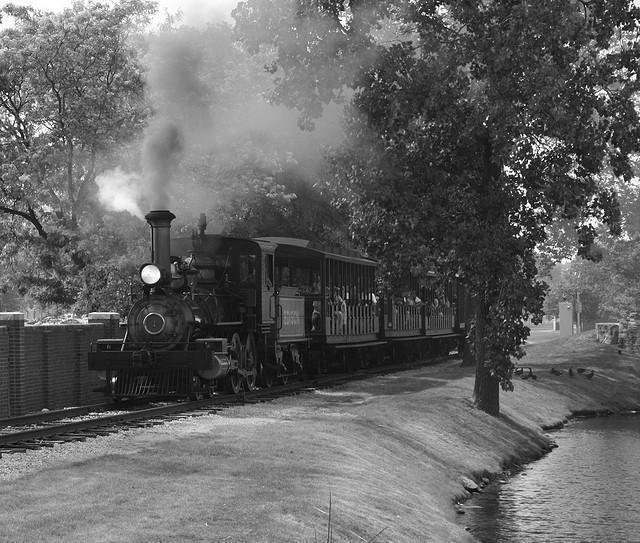What is the state of the colors here?
Indicate the correct choice and explain in the format: 'Answer: answer
Rationale: rationale.'
Options: Inverted, normal, black/white, super saturated. Answer: black/white.
Rationale: The colors are black and white. 